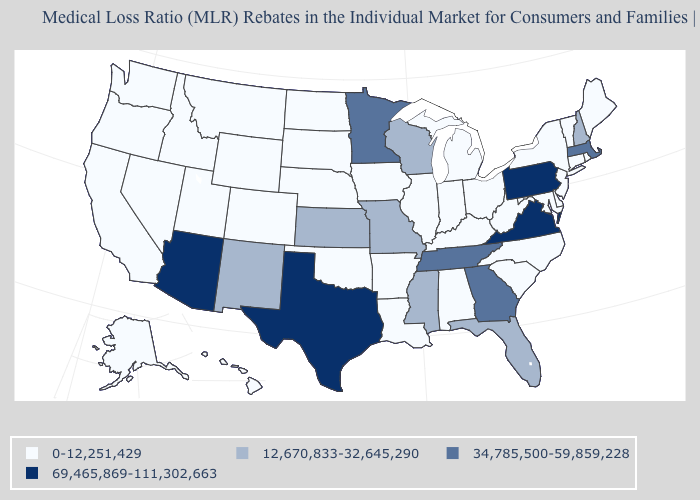Name the states that have a value in the range 0-12,251,429?
Give a very brief answer. Alabama, Alaska, Arkansas, California, Colorado, Connecticut, Delaware, Hawaii, Idaho, Illinois, Indiana, Iowa, Kentucky, Louisiana, Maine, Maryland, Michigan, Montana, Nebraska, Nevada, New Jersey, New York, North Carolina, North Dakota, Ohio, Oklahoma, Oregon, Rhode Island, South Carolina, South Dakota, Utah, Vermont, Washington, West Virginia, Wyoming. What is the value of Louisiana?
Concise answer only. 0-12,251,429. Is the legend a continuous bar?
Quick response, please. No. What is the value of Utah?
Answer briefly. 0-12,251,429. What is the lowest value in the USA?
Answer briefly. 0-12,251,429. Does Oregon have the lowest value in the USA?
Short answer required. Yes. Name the states that have a value in the range 0-12,251,429?
Be succinct. Alabama, Alaska, Arkansas, California, Colorado, Connecticut, Delaware, Hawaii, Idaho, Illinois, Indiana, Iowa, Kentucky, Louisiana, Maine, Maryland, Michigan, Montana, Nebraska, Nevada, New Jersey, New York, North Carolina, North Dakota, Ohio, Oklahoma, Oregon, Rhode Island, South Carolina, South Dakota, Utah, Vermont, Washington, West Virginia, Wyoming. Among the states that border New York , does Connecticut have the lowest value?
Write a very short answer. Yes. What is the value of Utah?
Be succinct. 0-12,251,429. Name the states that have a value in the range 69,465,869-111,302,663?
Give a very brief answer. Arizona, Pennsylvania, Texas, Virginia. What is the value of South Carolina?
Keep it brief. 0-12,251,429. Name the states that have a value in the range 69,465,869-111,302,663?
Keep it brief. Arizona, Pennsylvania, Texas, Virginia. What is the value of New Jersey?
Give a very brief answer. 0-12,251,429. What is the highest value in the USA?
Short answer required. 69,465,869-111,302,663. Which states have the highest value in the USA?
Keep it brief. Arizona, Pennsylvania, Texas, Virginia. 